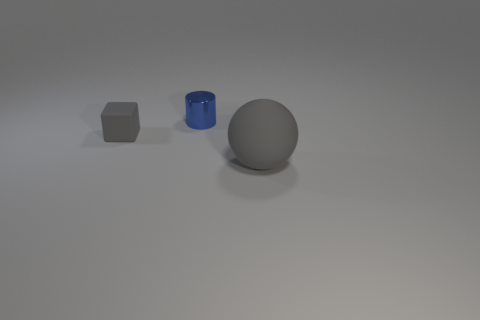Are there any other things that have the same size as the gray rubber ball?
Offer a very short reply. No. Is the color of the small block the same as the metal object?
Offer a terse response. No. What is the shape of the large thing that is the same color as the small matte cube?
Your answer should be very brief. Sphere. Is there any other thing that is the same material as the small blue cylinder?
Your response must be concise. No. There is a blue cylinder behind the small cube; does it have the same size as the gray thing on the right side of the metal thing?
Your answer should be very brief. No. The thing that is both left of the big sphere and in front of the small blue cylinder is made of what material?
Offer a very short reply. Rubber. Is there anything else that is the same color as the small shiny object?
Make the answer very short. No. Is the number of big objects that are right of the rubber sphere less than the number of brown rubber objects?
Ensure brevity in your answer.  No. Are there more small rubber objects than gray matte objects?
Provide a short and direct response. No. Is there a gray matte thing that is behind the gray rubber thing right of the matte object that is behind the big object?
Ensure brevity in your answer.  Yes. 